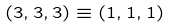<formula> <loc_0><loc_0><loc_500><loc_500>( 3 , 3 , 3 ) \equiv ( 1 , 1 , 1 )</formula> 